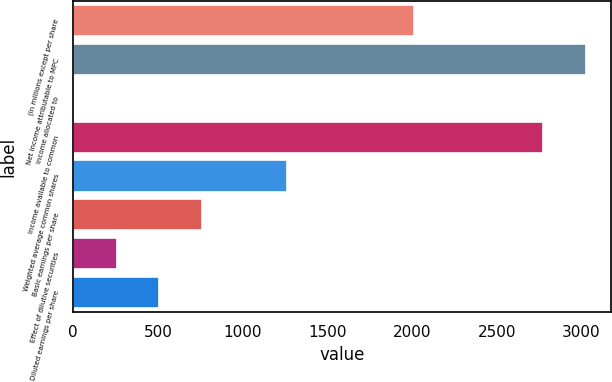Convert chart to OTSL. <chart><loc_0><loc_0><loc_500><loc_500><bar_chart><fcel>(In millions except per share<fcel>Net income attributable to MPC<fcel>Income allocated to<fcel>Income available to common<fcel>Weighted average common shares<fcel>Basic earnings per share<fcel>Effect of dilutive securities<fcel>Diluted earnings per share<nl><fcel>2014<fcel>3024<fcel>4<fcel>2772<fcel>1264<fcel>760<fcel>256<fcel>508<nl></chart> 